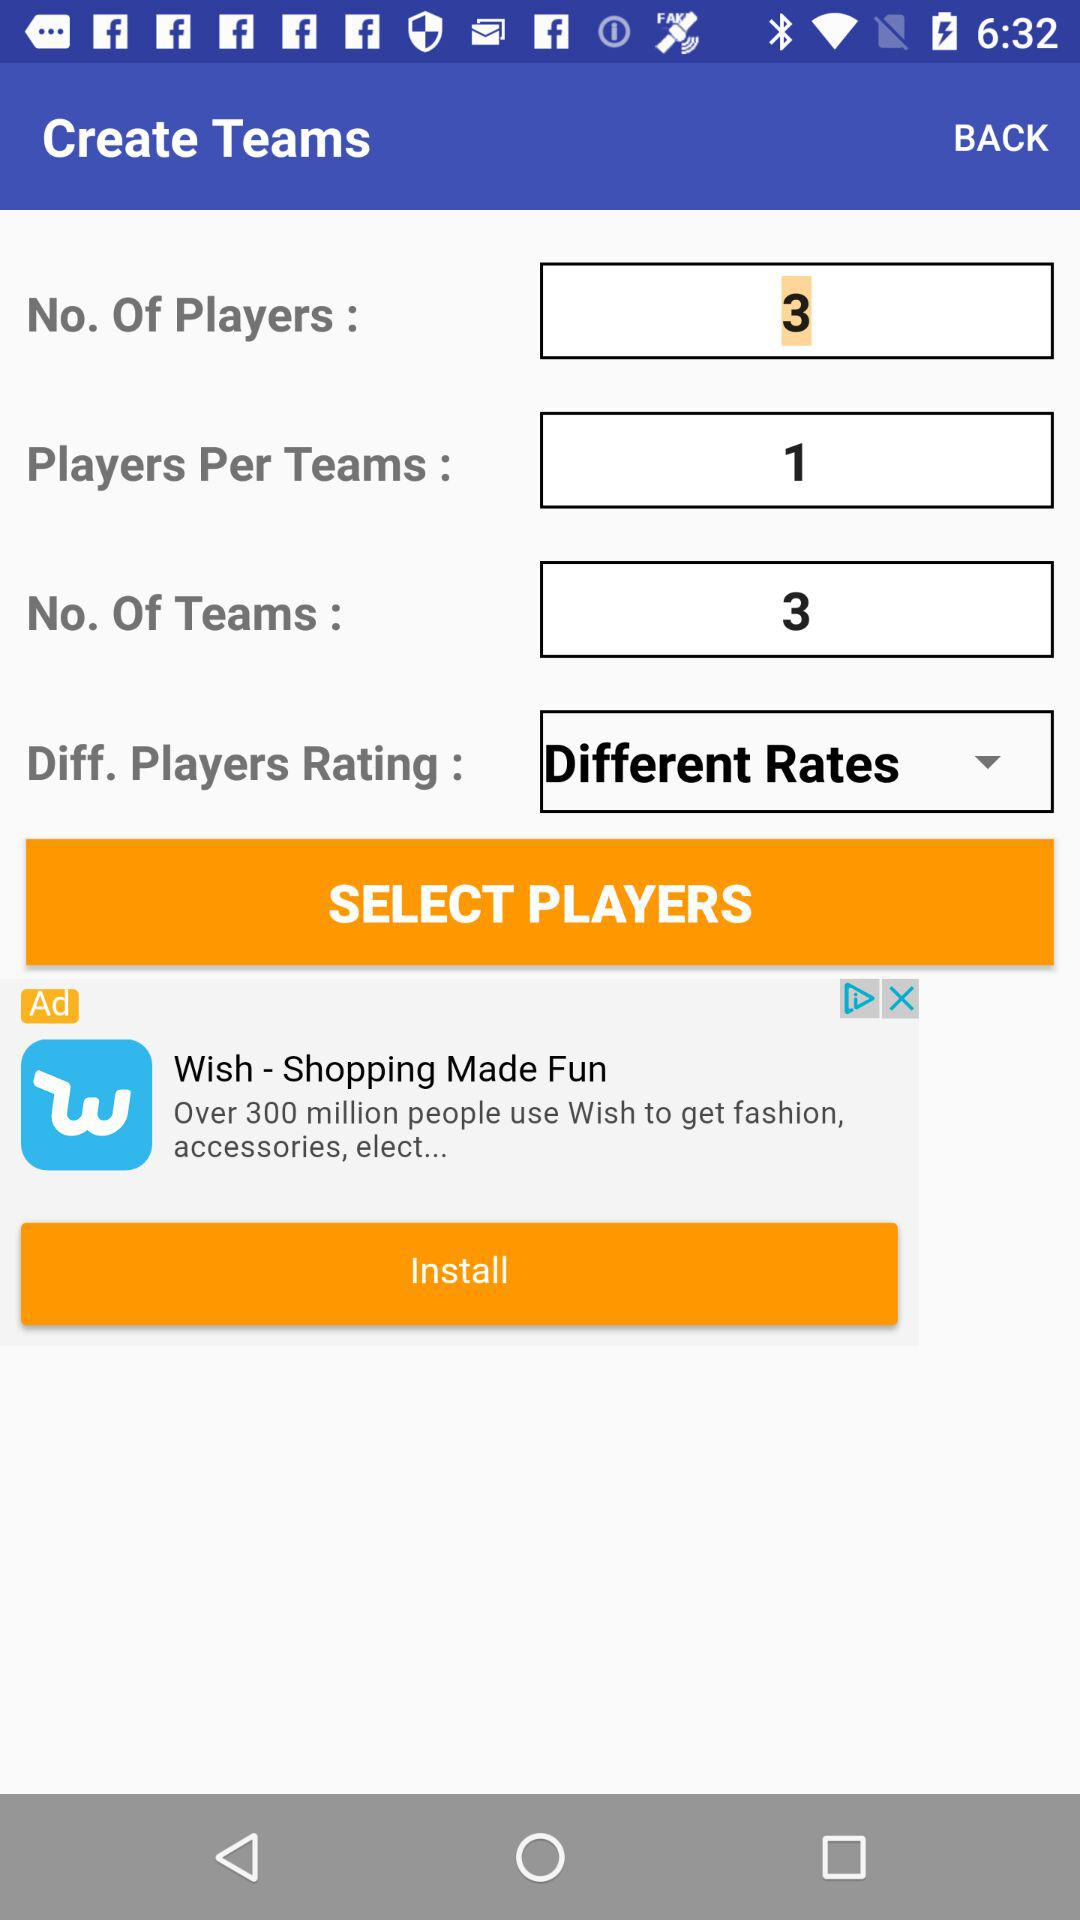What is the number of players per team? The number of players per team is 1. 